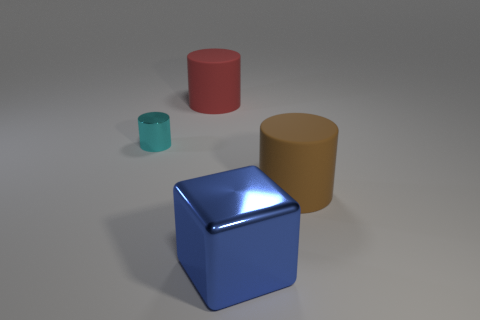Add 2 tiny green objects. How many objects exist? 6 Subtract all cylinders. How many objects are left? 1 Add 1 big green things. How many big green things exist? 1 Subtract 0 purple balls. How many objects are left? 4 Subtract all large blue rubber balls. Subtract all red matte objects. How many objects are left? 3 Add 2 tiny metallic things. How many tiny metallic things are left? 3 